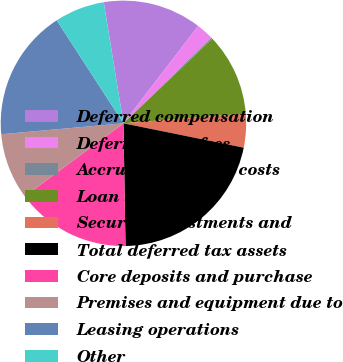<chart> <loc_0><loc_0><loc_500><loc_500><pie_chart><fcel>Deferred compensation<fcel>Deferred loan fees<fcel>Accrued severance costs<fcel>Loan sales<fcel>Security investments and<fcel>Total deferred tax assets<fcel>Core deposits and purchase<fcel>Premises and equipment due to<fcel>Leasing operations<fcel>Other<nl><fcel>12.99%<fcel>2.3%<fcel>0.16%<fcel>10.86%<fcel>4.44%<fcel>21.55%<fcel>15.13%<fcel>8.72%<fcel>17.27%<fcel>6.58%<nl></chart> 